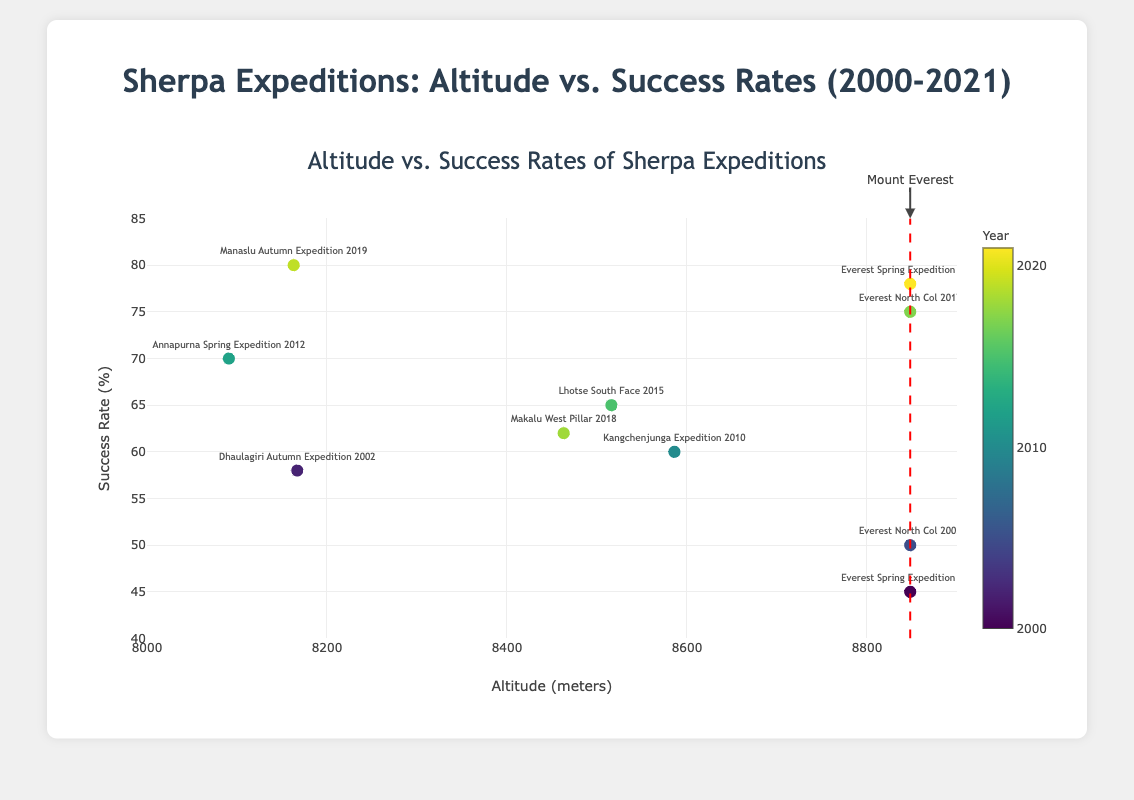How many expeditions reached an altitude of 8848 meters? To identify the number of expeditions that reached 8848 meters altitude, we can look for the data points aligned with this value on the x-axis. There are four such points, indicating four expeditions.
Answer: 4 What is the expedition with the highest success rate? Inspecting the y-values, the highest success rate is 80%, which corresponds to the "Manaslu Autumn Expedition 2019".
Answer: Manaslu Autumn Expedition 2019 Compare the success rates of the expeditions to Mount Everest taking place in 2000 and 2021. Which one is higher? Look for the expeditions named "Everest Spring Expedition 2000" and "Everest Spring Expedition 2021". The success rates are 45% and 78%, respectively. The 2021 expedition has a higher success rate.
Answer: Everest Spring Expedition 2021 Which expedition has the closest success rate to 60% but is not exactly 60%? On examining expeditions around the 60% success rate, "Lhotse South Face 2015" has a success rate of 65%, the closest but not exactly 60%.
Answer: Lhotse South Face 2015 What trend can be observed in success rates over time from 2000 to 2021? By analyzing data points' color variation and success rate increase, it can be observed that more recent expeditions tend to have higher success rates.
Answer: Success rates have generally increased over time What is the average success rate for expeditions that took place before 2010? Expeditions before 2010 have success rates of 45%, 58%, and 50%. The average is (45 + 58 + 50) / 3 = 51%.
Answer: 51% What is the difference in altitude between the "Everest North Col 2017" and "Annapurna Spring Expedition 2012"? Everest North Col 2017 has an altitude of 8848 meters, while Annapurna Spring Expedition 2012 has 8091 meters. The difference is 8848 - 8091 = 757 meters.
Answer: 757 meters Is there any expedition noted to have a precisely 70% success rate? By locating exact y-value of 70%, the "Annapurna Spring Expedition 2012" has a 70% success rate.
Answer: Annapurna Spring Expedition 2012 How many data points indicate expeditions above 8500 meters? Data points with x-values above 8500 meters are associated with altitudes like 8586, 8516, and multiple 8848 entries. Counting these gives five expeditions.
Answer: 5 Which two expeditions closest to each other in year also have their success rates within a 5% range of one another? The two expeditions from 2018 and 2019 ("Makalu West Pillar 2018" and "Manaslu Autumn Expedition 2019") are closest in year and have success rates within a 5% range (62% and 80%)
Answer: No expeditions meet both conditions 